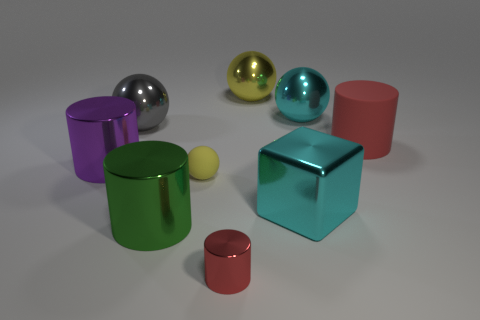Subtract all green blocks. How many red cylinders are left? 2 Subtract all big cylinders. How many cylinders are left? 1 Subtract all purple cylinders. How many cylinders are left? 3 Add 1 large yellow objects. How many objects exist? 10 Subtract all blue cylinders. Subtract all gray blocks. How many cylinders are left? 4 Subtract all cylinders. How many objects are left? 5 Add 5 big cyan metallic objects. How many big cyan metallic objects are left? 7 Add 3 red shiny balls. How many red shiny balls exist? 3 Subtract 0 purple balls. How many objects are left? 9 Subtract all large brown blocks. Subtract all large cyan shiny objects. How many objects are left? 7 